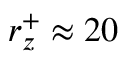<formula> <loc_0><loc_0><loc_500><loc_500>r _ { z } ^ { + } \approx 2 0</formula> 